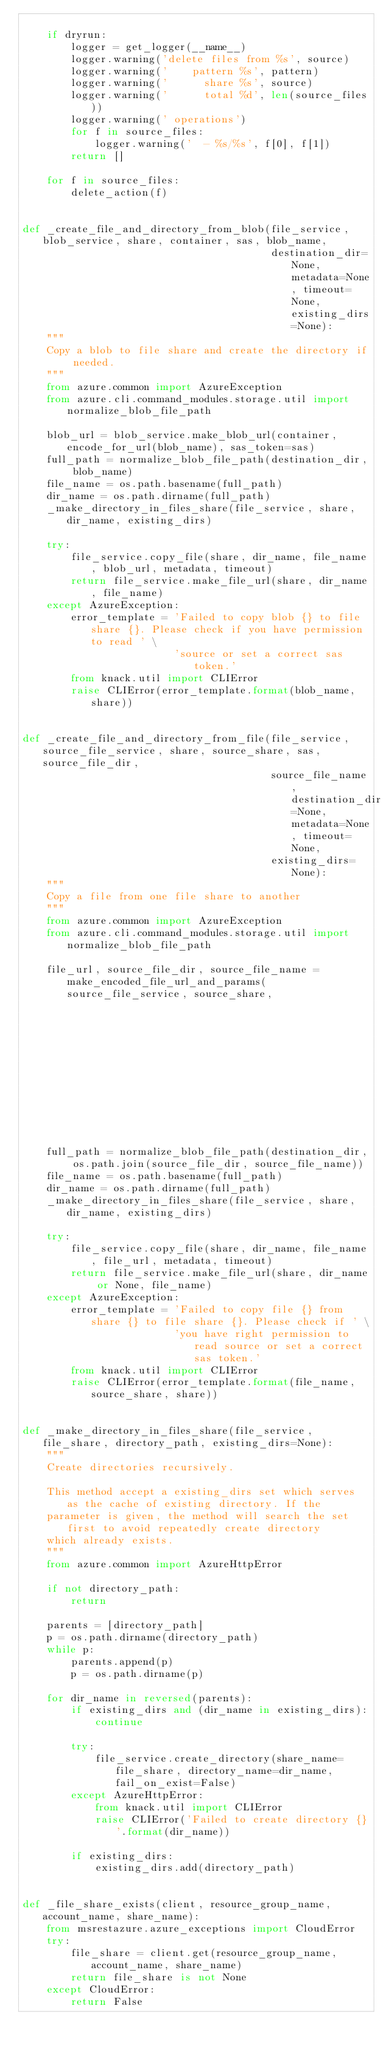Convert code to text. <code><loc_0><loc_0><loc_500><loc_500><_Python_>
    if dryrun:
        logger = get_logger(__name__)
        logger.warning('delete files from %s', source)
        logger.warning('    pattern %s', pattern)
        logger.warning('      share %s', source)
        logger.warning('      total %d', len(source_files))
        logger.warning(' operations')
        for f in source_files:
            logger.warning('  - %s/%s', f[0], f[1])
        return []

    for f in source_files:
        delete_action(f)


def _create_file_and_directory_from_blob(file_service, blob_service, share, container, sas, blob_name,
                                         destination_dir=None, metadata=None, timeout=None, existing_dirs=None):
    """
    Copy a blob to file share and create the directory if needed.
    """
    from azure.common import AzureException
    from azure.cli.command_modules.storage.util import normalize_blob_file_path

    blob_url = blob_service.make_blob_url(container, encode_for_url(blob_name), sas_token=sas)
    full_path = normalize_blob_file_path(destination_dir, blob_name)
    file_name = os.path.basename(full_path)
    dir_name = os.path.dirname(full_path)
    _make_directory_in_files_share(file_service, share, dir_name, existing_dirs)

    try:
        file_service.copy_file(share, dir_name, file_name, blob_url, metadata, timeout)
        return file_service.make_file_url(share, dir_name, file_name)
    except AzureException:
        error_template = 'Failed to copy blob {} to file share {}. Please check if you have permission to read ' \
                         'source or set a correct sas token.'
        from knack.util import CLIError
        raise CLIError(error_template.format(blob_name, share))


def _create_file_and_directory_from_file(file_service, source_file_service, share, source_share, sas, source_file_dir,
                                         source_file_name, destination_dir=None, metadata=None, timeout=None,
                                         existing_dirs=None):
    """
    Copy a file from one file share to another
    """
    from azure.common import AzureException
    from azure.cli.command_modules.storage.util import normalize_blob_file_path

    file_url, source_file_dir, source_file_name = make_encoded_file_url_and_params(source_file_service, source_share,
                                                                                   source_file_dir, source_file_name,
                                                                                   sas_token=sas)

    full_path = normalize_blob_file_path(destination_dir, os.path.join(source_file_dir, source_file_name))
    file_name = os.path.basename(full_path)
    dir_name = os.path.dirname(full_path)
    _make_directory_in_files_share(file_service, share, dir_name, existing_dirs)

    try:
        file_service.copy_file(share, dir_name, file_name, file_url, metadata, timeout)
        return file_service.make_file_url(share, dir_name or None, file_name)
    except AzureException:
        error_template = 'Failed to copy file {} from share {} to file share {}. Please check if ' \
                         'you have right permission to read source or set a correct sas token.'
        from knack.util import CLIError
        raise CLIError(error_template.format(file_name, source_share, share))


def _make_directory_in_files_share(file_service, file_share, directory_path, existing_dirs=None):
    """
    Create directories recursively.

    This method accept a existing_dirs set which serves as the cache of existing directory. If the
    parameter is given, the method will search the set first to avoid repeatedly create directory
    which already exists.
    """
    from azure.common import AzureHttpError

    if not directory_path:
        return

    parents = [directory_path]
    p = os.path.dirname(directory_path)
    while p:
        parents.append(p)
        p = os.path.dirname(p)

    for dir_name in reversed(parents):
        if existing_dirs and (dir_name in existing_dirs):
            continue

        try:
            file_service.create_directory(share_name=file_share, directory_name=dir_name, fail_on_exist=False)
        except AzureHttpError:
            from knack.util import CLIError
            raise CLIError('Failed to create directory {}'.format(dir_name))

        if existing_dirs:
            existing_dirs.add(directory_path)


def _file_share_exists(client, resource_group_name, account_name, share_name):
    from msrestazure.azure_exceptions import CloudError
    try:
        file_share = client.get(resource_group_name, account_name, share_name)
        return file_share is not None
    except CloudError:
        return False
</code> 